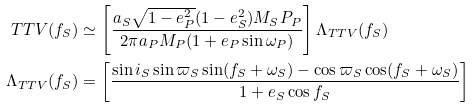Convert formula to latex. <formula><loc_0><loc_0><loc_500><loc_500>T T V ( f _ { S } ) & \simeq \left [ \frac { a _ { S } \sqrt { 1 - e _ { P } ^ { 2 } } ( 1 - e _ { S } ^ { 2 } ) M _ { S } P _ { P } } { 2 \pi a _ { P } M _ { P } ( 1 + e _ { P } \sin \omega _ { P } ) } \right ] \Lambda _ { T T V } ( f _ { S } ) \\ \Lambda _ { T T V } ( f _ { S } ) & = \left [ \frac { \sin i _ { S } \sin \varpi _ { S } \sin ( f _ { S } + \omega _ { S } ) - \cos \varpi _ { S } \cos ( f _ { S } + \omega _ { S } ) } { 1 + e _ { S } \cos f _ { S } } \right ]</formula> 